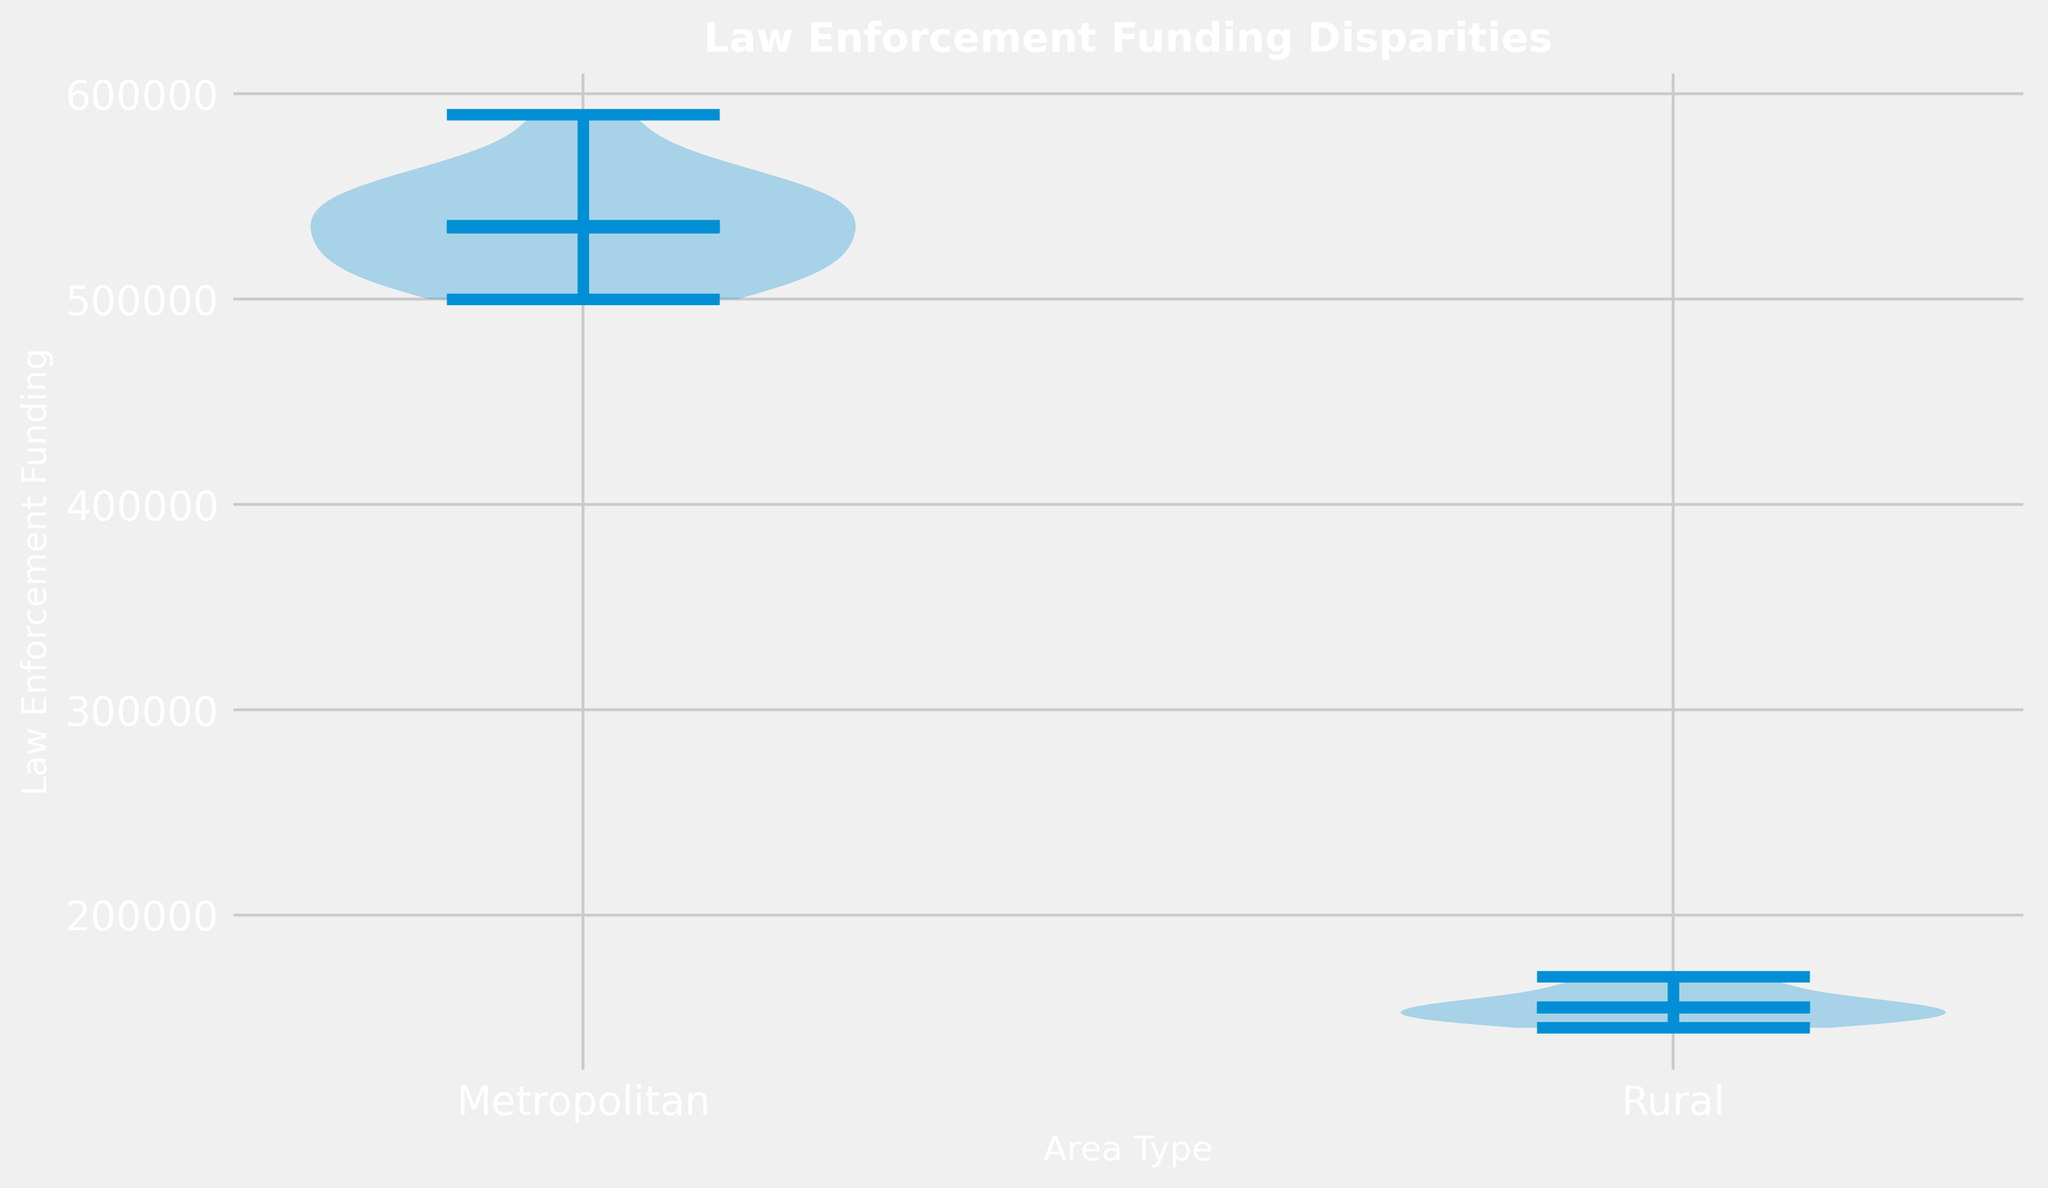What is the mean Law Enforcement Funding for Metropolitan areas? The blue horizontal line in the middle of the Metropolitan violin plot shows the mean. It's the average of all values within the Metropolitan dataset.
Answer: 535000 Which area, Metropolitan or Rural, has a higher median Law Enforcement Funding? The median is depicted by a white dot within the violins. For Metropolitan, the median dot is higher compared to the Rural area.
Answer: Metropolitan What is the range of Law Enforcement Funding for Rural areas? The range is the difference between the highest and lowest points on the violin plot for Rural areas. This requires identifying the upper and lower extremes.
Answer: 145000—170000 Which area type shows a wider distribution of Law Enforcement Funding, Metropolitan or Rural? The width of the violin plot at various points indicates distribution. A wider plot shows greater funding variability. The Metropolitan plot is visibly wider across the range.
Answer: Metropolitan Are the means and medians for Law Enforcement Funding close to each other in both area types? Comparing the blue horizontal lines (means) and the white dots (medians) within each violin plot will show their proximity. In both cases, they are close but slightly different.
Answer: Yes, close How does the interquartile range (IQR) for Law Enforcement Funding compare between Metropolitan and Rural areas? The IQR can be inferred from the density and spread within the central 50% of each violin plot. The Metropolitan area has a taller and more stretched central region, indicating a potentially larger IQR.
Answer: Metropolitan has a larger IQR What is the approximate difference in mean Law Enforcement Funding between Metropolitan and Rural areas? Compare the blue horizontal lines of the two violins. The mean for Metropolitan is around 540,000 and for Rural it is around 155,000. The difference would be the difference between these means.
Answer: 385000 Do Rural areas show more uniformity in Law Enforcement Funding compared to Metropolitan areas? Uniformity can be assessed by how narrow and consistent the violin plot is. The Rural plot is narrower, indicating less variability in funding.
Answer: Yes How much higher is the maximum Law Enforcement Funding in Metropolitan areas compared to Rural areas? Identify the topmost point of each violin plot. The maximum for Metropolitan is around 590,000, and for Rural it's around 170,000, comparing these gives the difference.
Answer: 420000 